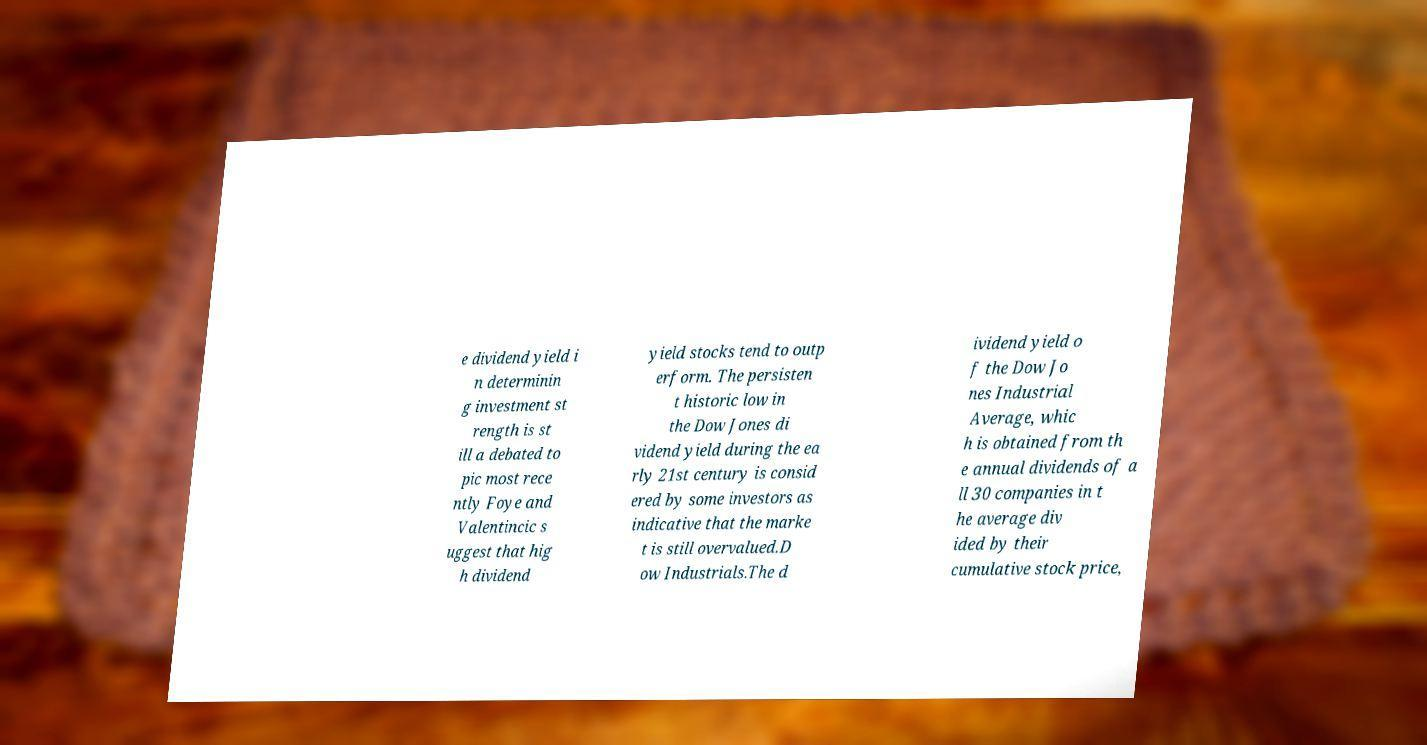Please read and relay the text visible in this image. What does it say? e dividend yield i n determinin g investment st rength is st ill a debated to pic most rece ntly Foye and Valentincic s uggest that hig h dividend yield stocks tend to outp erform. The persisten t historic low in the Dow Jones di vidend yield during the ea rly 21st century is consid ered by some investors as indicative that the marke t is still overvalued.D ow Industrials.The d ividend yield o f the Dow Jo nes Industrial Average, whic h is obtained from th e annual dividends of a ll 30 companies in t he average div ided by their cumulative stock price, 